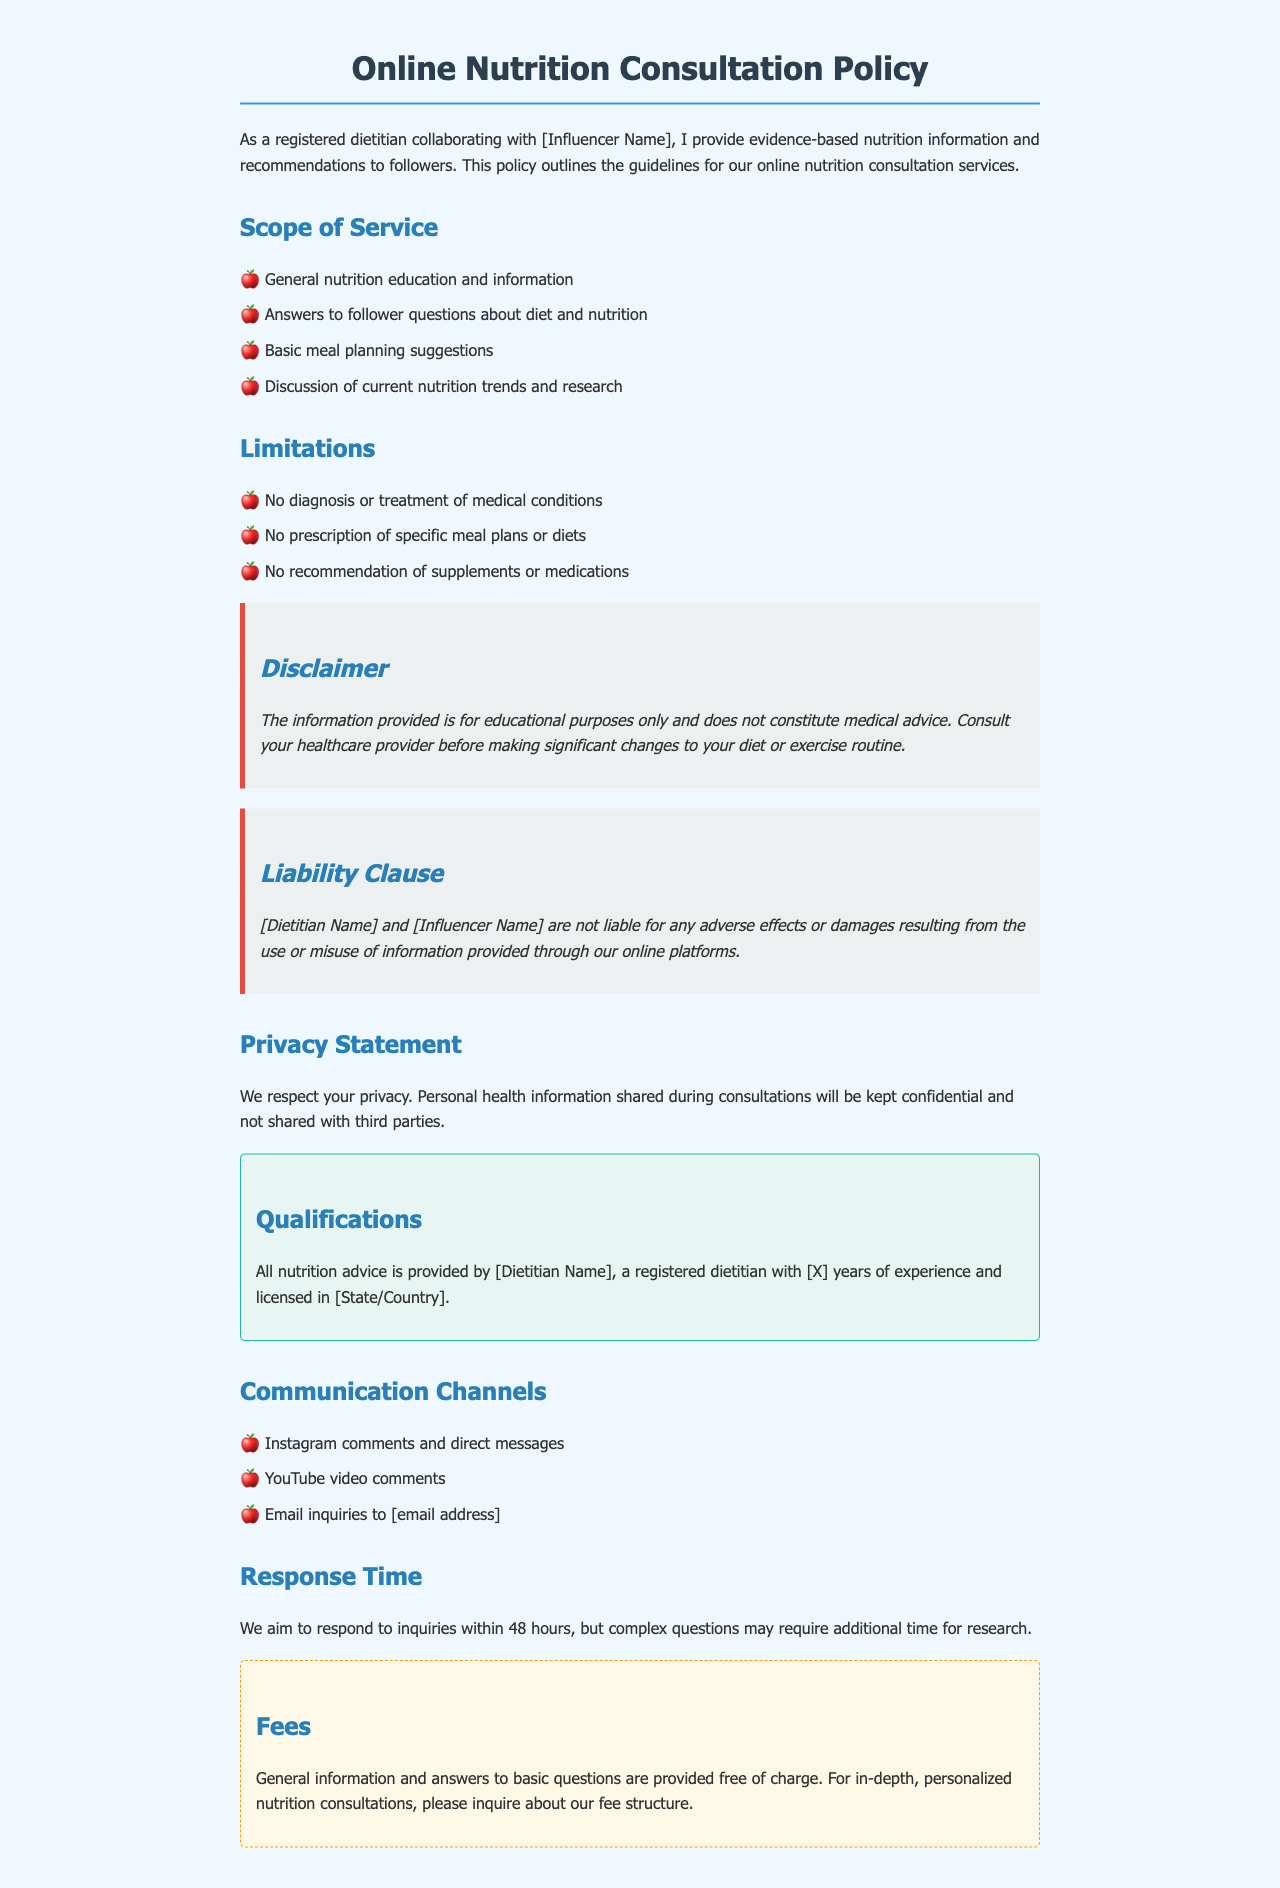What services are provided in the online consultation? The services are outlined in the "Scope of Service" section of the document, which includes general nutrition education, answering follower questions, meal planning suggestions, and discussing nutrition trends.
Answer: General nutrition education and information How long does the dietitian claim to have experience? The number of years of experience is mentioned in the "Qualifications" section, where the dietitian's experience is quantified.
Answer: [X] years What is the response time aimed for inquiries? The document specifies the expected response time in the "Response Time" section, highlighting standard expectations for communication.
Answer: 48 hours Are any supplements recommended in the consultations? The "Limitations" section explicitly states what is not included in the consultations, which helps clarify the advice that is not provided.
Answer: No What are the communication channels mentioned? The document lists the various ways followers can reach out in the "Communication Channels" section, specifying platforms for inquiries.
Answer: Instagram comments and direct messages What is the purpose of the information provided? The "Disclaimer" section specifies the purpose and nature of the information shared, clarifying how it should be perceived by followers.
Answer: Educational purposes only Who is not liable for adverse effects from the advice? The "Liability Clause" names the parties that disclaim liability for issues arising from the information shared during online consultations.
Answer: [Dietitian Name] and [Influencer Name] Is there a fee for general information? The "Fees" section delineates which services incur charges and which do not, providing clarity on costs associated with inquiries.
Answer: Free of charge 